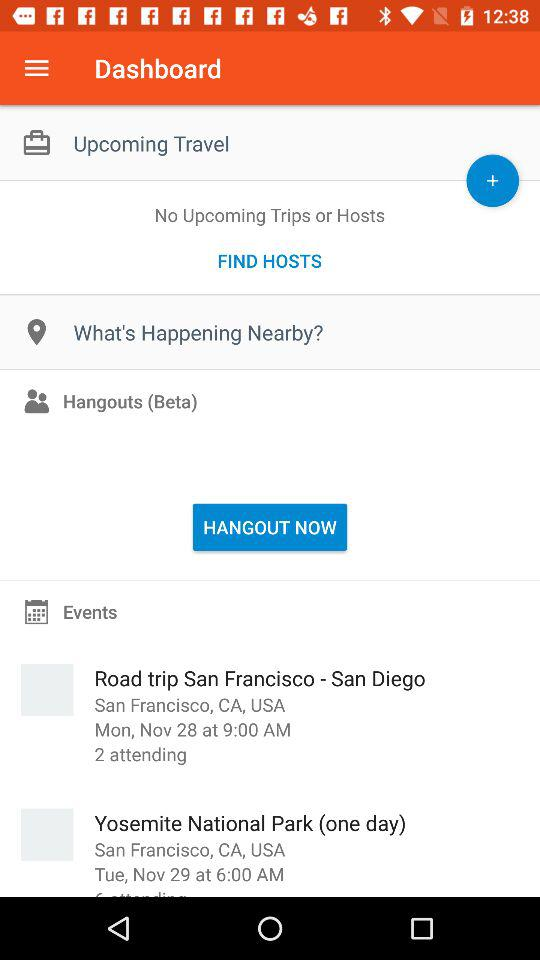How many people are attending the "Road trip San Francisco - San Diego" event? The number of people attending the "Road trip San Francisco - San Diego" event is 2. 